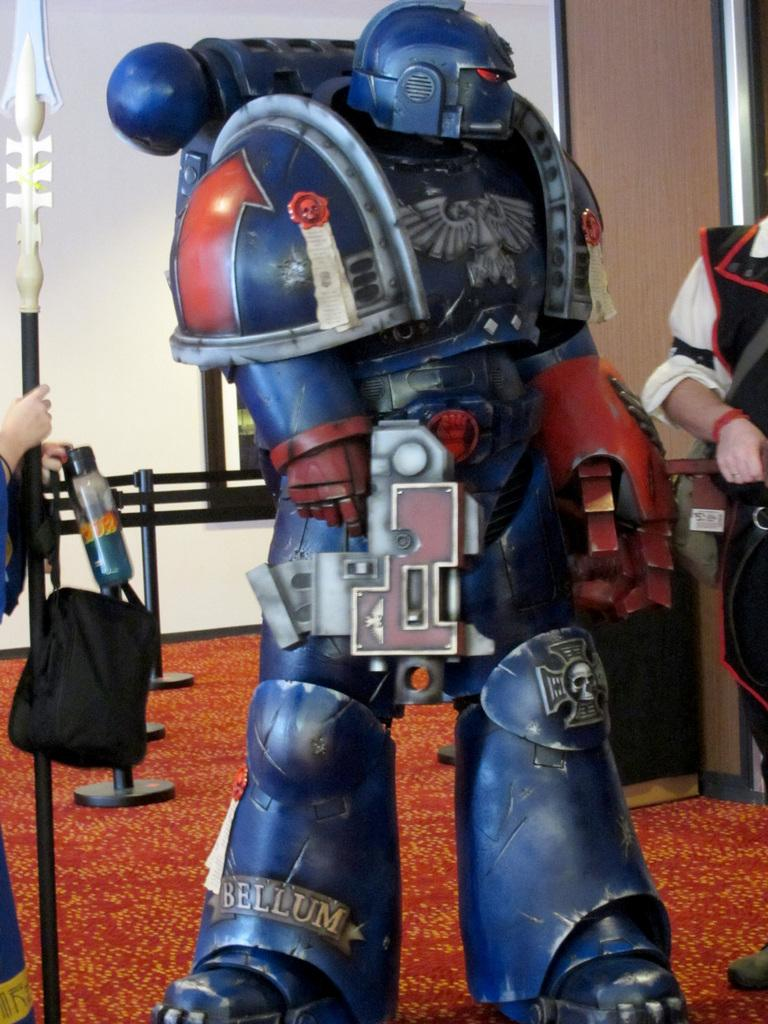What type of toy is in the image? There is a transformer-shaped toy in the image. What color is the toy? The toy is blue in color. Who is present in the image? There is a man standing on the right side of the image. What is at the bottom of the image? There is a floor mat at the bottom of the image. What type of downtown scene can be seen in the image? There is no downtown scene present in the image; it features a transformer-shaped toy, a man, and a floor mat. What type of library is visible in the image? There is no library present in the image. 